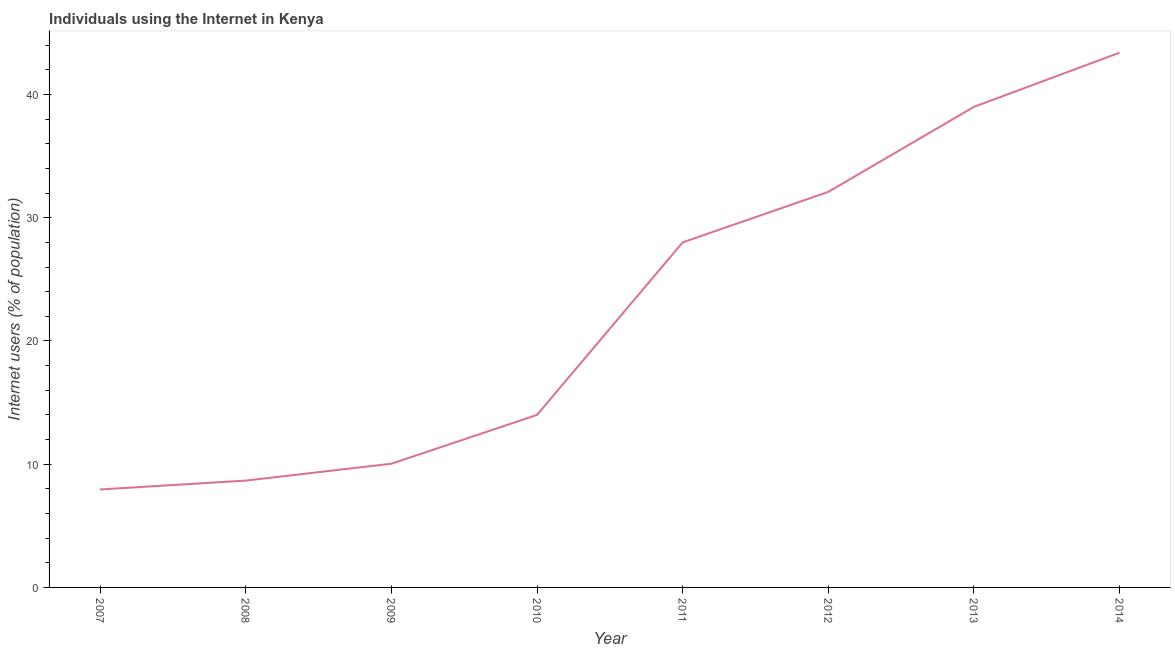What is the number of internet users in 2007?
Keep it short and to the point. 7.95. Across all years, what is the maximum number of internet users?
Offer a very short reply. 43.4. Across all years, what is the minimum number of internet users?
Your response must be concise. 7.95. What is the sum of the number of internet users?
Your answer should be very brief. 183.16. What is the difference between the number of internet users in 2007 and 2013?
Make the answer very short. -31.05. What is the average number of internet users per year?
Make the answer very short. 22.89. Do a majority of the years between 2009 and 2012 (inclusive) have number of internet users greater than 36 %?
Keep it short and to the point. No. What is the ratio of the number of internet users in 2009 to that in 2011?
Your answer should be compact. 0.36. What is the difference between the highest and the second highest number of internet users?
Give a very brief answer. 4.4. Is the sum of the number of internet users in 2009 and 2010 greater than the maximum number of internet users across all years?
Keep it short and to the point. No. What is the difference between the highest and the lowest number of internet users?
Give a very brief answer. 35.45. In how many years, is the number of internet users greater than the average number of internet users taken over all years?
Provide a short and direct response. 4. Does the number of internet users monotonically increase over the years?
Give a very brief answer. Yes. Does the graph contain any zero values?
Provide a short and direct response. No. What is the title of the graph?
Provide a short and direct response. Individuals using the Internet in Kenya. What is the label or title of the Y-axis?
Provide a short and direct response. Internet users (% of population). What is the Internet users (% of population) of 2007?
Provide a succinct answer. 7.95. What is the Internet users (% of population) of 2008?
Provide a succinct answer. 8.67. What is the Internet users (% of population) of 2009?
Ensure brevity in your answer.  10.04. What is the Internet users (% of population) in 2012?
Provide a short and direct response. 32.1. What is the Internet users (% of population) in 2014?
Provide a short and direct response. 43.4. What is the difference between the Internet users (% of population) in 2007 and 2008?
Make the answer very short. -0.72. What is the difference between the Internet users (% of population) in 2007 and 2009?
Your response must be concise. -2.09. What is the difference between the Internet users (% of population) in 2007 and 2010?
Provide a short and direct response. -6.05. What is the difference between the Internet users (% of population) in 2007 and 2011?
Provide a short and direct response. -20.05. What is the difference between the Internet users (% of population) in 2007 and 2012?
Make the answer very short. -24.15. What is the difference between the Internet users (% of population) in 2007 and 2013?
Make the answer very short. -31.05. What is the difference between the Internet users (% of population) in 2007 and 2014?
Ensure brevity in your answer.  -35.45. What is the difference between the Internet users (% of population) in 2008 and 2009?
Keep it short and to the point. -1.37. What is the difference between the Internet users (% of population) in 2008 and 2010?
Offer a very short reply. -5.33. What is the difference between the Internet users (% of population) in 2008 and 2011?
Provide a succinct answer. -19.33. What is the difference between the Internet users (% of population) in 2008 and 2012?
Provide a succinct answer. -23.43. What is the difference between the Internet users (% of population) in 2008 and 2013?
Provide a short and direct response. -30.33. What is the difference between the Internet users (% of population) in 2008 and 2014?
Provide a succinct answer. -34.73. What is the difference between the Internet users (% of population) in 2009 and 2010?
Ensure brevity in your answer.  -3.96. What is the difference between the Internet users (% of population) in 2009 and 2011?
Provide a short and direct response. -17.96. What is the difference between the Internet users (% of population) in 2009 and 2012?
Provide a succinct answer. -22.06. What is the difference between the Internet users (% of population) in 2009 and 2013?
Your answer should be very brief. -28.96. What is the difference between the Internet users (% of population) in 2009 and 2014?
Your answer should be very brief. -33.36. What is the difference between the Internet users (% of population) in 2010 and 2012?
Provide a succinct answer. -18.1. What is the difference between the Internet users (% of population) in 2010 and 2013?
Offer a terse response. -25. What is the difference between the Internet users (% of population) in 2010 and 2014?
Ensure brevity in your answer.  -29.4. What is the difference between the Internet users (% of population) in 2011 and 2012?
Offer a very short reply. -4.1. What is the difference between the Internet users (% of population) in 2011 and 2014?
Provide a succinct answer. -15.4. What is the ratio of the Internet users (% of population) in 2007 to that in 2008?
Provide a short and direct response. 0.92. What is the ratio of the Internet users (% of population) in 2007 to that in 2009?
Provide a short and direct response. 0.79. What is the ratio of the Internet users (% of population) in 2007 to that in 2010?
Your answer should be very brief. 0.57. What is the ratio of the Internet users (% of population) in 2007 to that in 2011?
Keep it short and to the point. 0.28. What is the ratio of the Internet users (% of population) in 2007 to that in 2012?
Offer a terse response. 0.25. What is the ratio of the Internet users (% of population) in 2007 to that in 2013?
Ensure brevity in your answer.  0.2. What is the ratio of the Internet users (% of population) in 2007 to that in 2014?
Provide a succinct answer. 0.18. What is the ratio of the Internet users (% of population) in 2008 to that in 2009?
Give a very brief answer. 0.86. What is the ratio of the Internet users (% of population) in 2008 to that in 2010?
Your response must be concise. 0.62. What is the ratio of the Internet users (% of population) in 2008 to that in 2011?
Your answer should be compact. 0.31. What is the ratio of the Internet users (% of population) in 2008 to that in 2012?
Ensure brevity in your answer.  0.27. What is the ratio of the Internet users (% of population) in 2008 to that in 2013?
Offer a terse response. 0.22. What is the ratio of the Internet users (% of population) in 2008 to that in 2014?
Provide a short and direct response. 0.2. What is the ratio of the Internet users (% of population) in 2009 to that in 2010?
Your answer should be very brief. 0.72. What is the ratio of the Internet users (% of population) in 2009 to that in 2011?
Your answer should be very brief. 0.36. What is the ratio of the Internet users (% of population) in 2009 to that in 2012?
Give a very brief answer. 0.31. What is the ratio of the Internet users (% of population) in 2009 to that in 2013?
Give a very brief answer. 0.26. What is the ratio of the Internet users (% of population) in 2009 to that in 2014?
Provide a succinct answer. 0.23. What is the ratio of the Internet users (% of population) in 2010 to that in 2012?
Keep it short and to the point. 0.44. What is the ratio of the Internet users (% of population) in 2010 to that in 2013?
Provide a succinct answer. 0.36. What is the ratio of the Internet users (% of population) in 2010 to that in 2014?
Offer a very short reply. 0.32. What is the ratio of the Internet users (% of population) in 2011 to that in 2012?
Your response must be concise. 0.87. What is the ratio of the Internet users (% of population) in 2011 to that in 2013?
Make the answer very short. 0.72. What is the ratio of the Internet users (% of population) in 2011 to that in 2014?
Ensure brevity in your answer.  0.65. What is the ratio of the Internet users (% of population) in 2012 to that in 2013?
Make the answer very short. 0.82. What is the ratio of the Internet users (% of population) in 2012 to that in 2014?
Your response must be concise. 0.74. What is the ratio of the Internet users (% of population) in 2013 to that in 2014?
Provide a short and direct response. 0.9. 